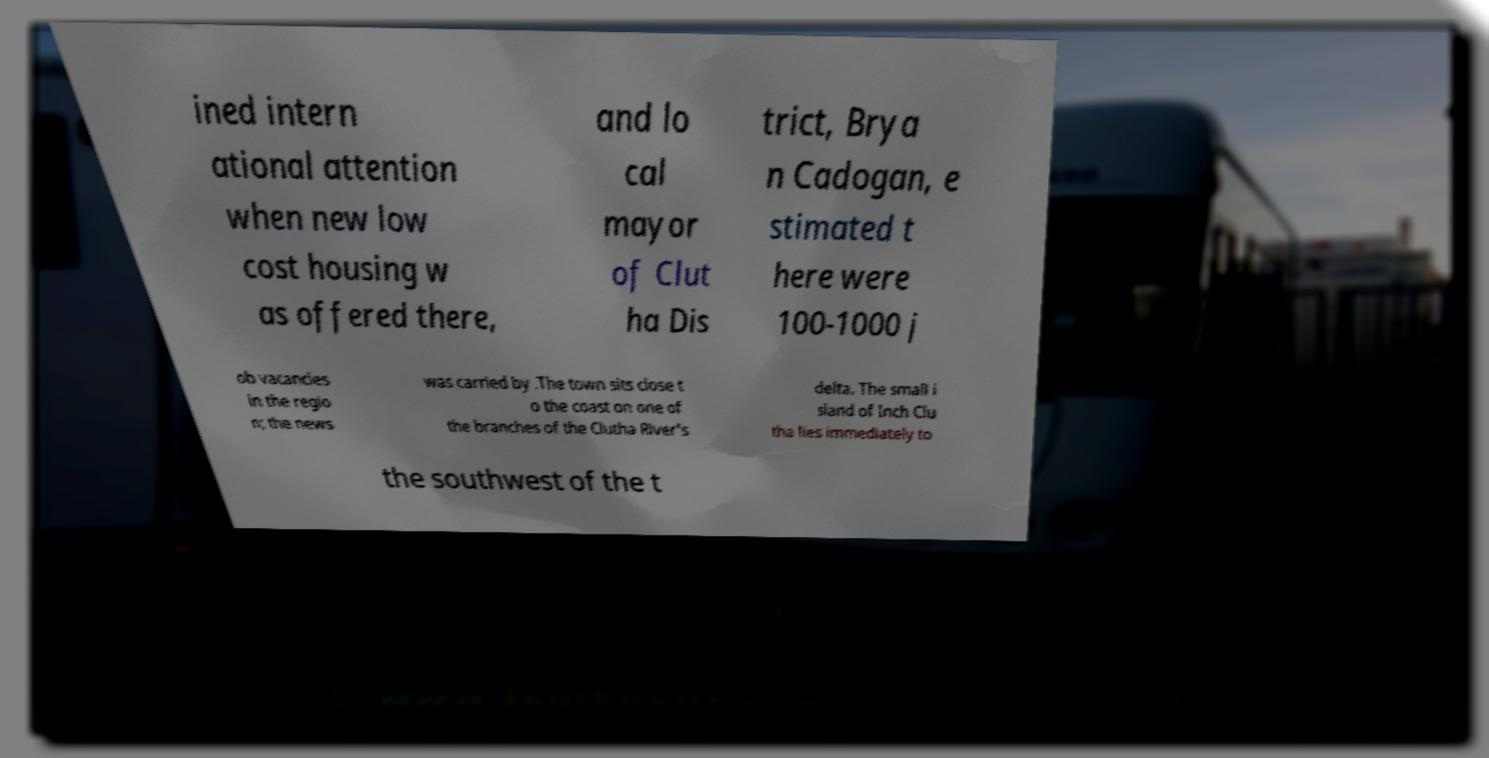Please read and relay the text visible in this image. What does it say? ined intern ational attention when new low cost housing w as offered there, and lo cal mayor of Clut ha Dis trict, Brya n Cadogan, e stimated t here were 100-1000 j ob vacancies in the regio n; the news was carried by .The town sits close t o the coast on one of the branches of the Clutha River's delta. The small i sland of Inch Clu tha lies immediately to the southwest of the t 